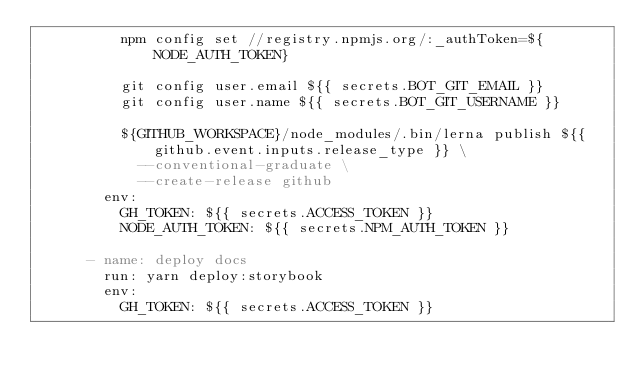Convert code to text. <code><loc_0><loc_0><loc_500><loc_500><_YAML_>          npm config set //registry.npmjs.org/:_authToken=${NODE_AUTH_TOKEN}

          git config user.email ${{ secrets.BOT_GIT_EMAIL }}
          git config user.name ${{ secrets.BOT_GIT_USERNAME }}

          ${GITHUB_WORKSPACE}/node_modules/.bin/lerna publish ${{ github.event.inputs.release_type }} \
            --conventional-graduate \
            --create-release github
        env:
          GH_TOKEN: ${{ secrets.ACCESS_TOKEN }}
          NODE_AUTH_TOKEN: ${{ secrets.NPM_AUTH_TOKEN }}

      - name: deploy docs
        run: yarn deploy:storybook
        env:
          GH_TOKEN: ${{ secrets.ACCESS_TOKEN }}
</code> 